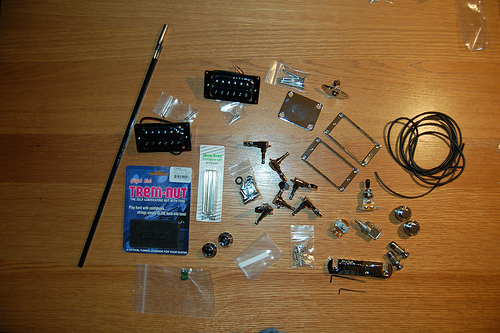<image>
Is there a book above the cover? Yes. The book is positioned above the cover in the vertical space, higher up in the scene. 